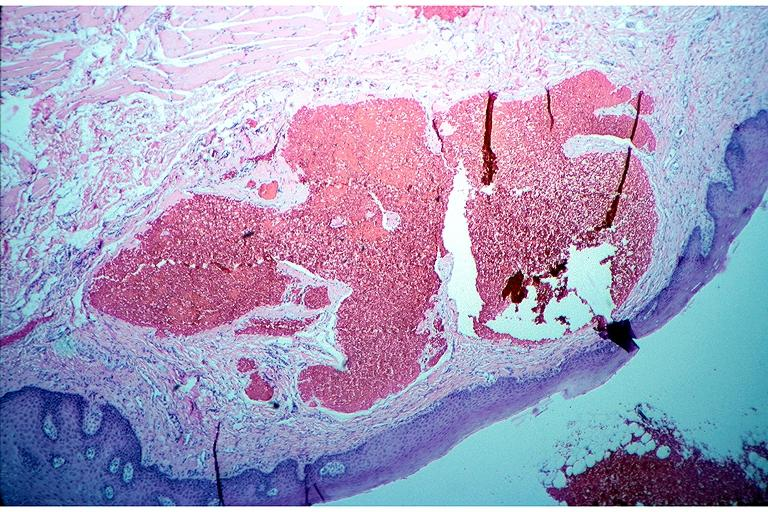what is present?
Answer the question using a single word or phrase. Oral 